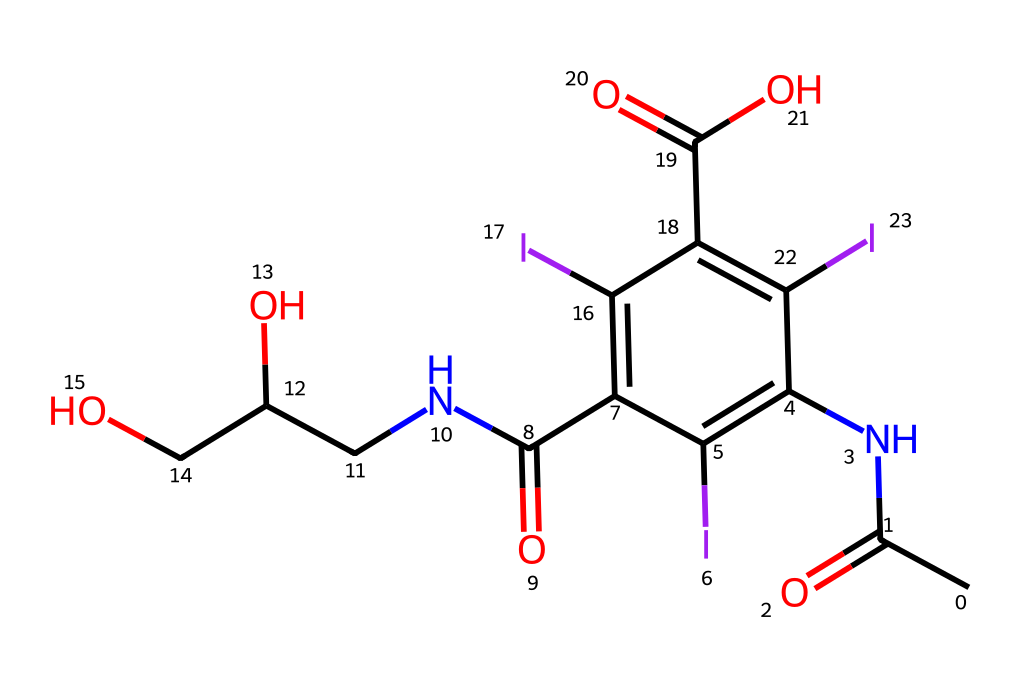How many iodine atoms are present in this chemical structure? By examining the SMILES representation, the letter "I" indicates the presence of iodine atoms. Counting all the occurrences of "I" in the given structure yields four iodine atoms.
Answer: four What are the functional groups present in this molecule? Analyzing the SMILES, we identify amide (–C(=O)N–), hydroxyl (–OH), and carboxylic acid (–C(=O)O) functional groups. These can be recognized by their distinct bonding patterns seen in the structure.
Answer: amide, hydroxyl, carboxylic acid What is the degree of substitution of iodine in the benzene ring? In the structure, the benzene ring contains three iodine substituents. The degree of substitution refers to the number of substituents attached to the benzene, which can be counted from the positions of the I atoms on the ring.
Answer: three What type of chemical bonding is present between iodine and the benzene structure? Iodine typically forms a single covalent bond with carbon in the benzene structure based on the drawing. This bonding can be inferred from the single connection made by the iodine substituents to the aromatic ring.
Answer: single covalent bond What role does iodine play in medical imaging contrast agents? Iodine is known for its high atomic number, which allows it to effectively absorb X-rays. This property enhances the contrast in imaging, making iodine a crucial component in medical imaging contrast agents.
Answer: contrast enhancement How many total atoms are in this chemical structure? Counting each distinct atom represented in the SMILES—carbons, hydrogens, nitrogens, oxygens, and iodines—yields a total of 21 atoms when summed together.
Answer: twenty-one 